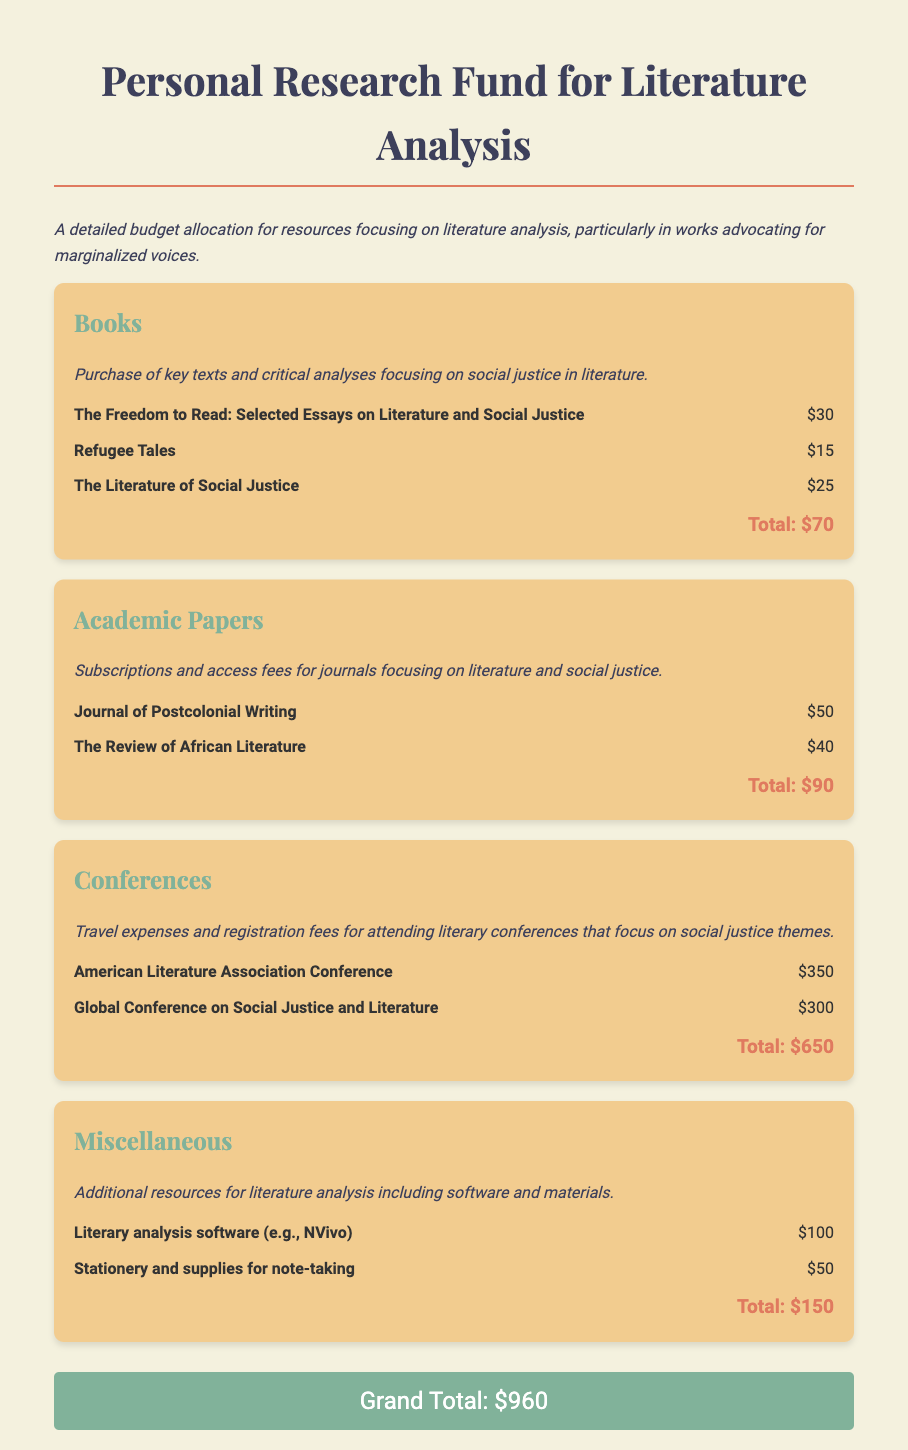What is the title of the budget document? The title of the budget document is stated clearly at the top of the rendered document.
Answer: Personal Research Fund for Literature Analysis What is the total amount allocated for books? This total is calculated from the individual costs of the books provided in the document.
Answer: $70 How much is budgeted for academic papers? The total allocated for academic papers can be found in the respective section of the document.
Answer: $90 What is the registration fee for the American Literature Association Conference? This fee is specified in the conference section of the document.
Answer: $350 What is the total amount allocated for conferences? This sum includes the costs of all listed conferences and is presented as a total in that section.
Answer: $650 What are the expenses listed under miscellaneous? This section includes costs for additional resources necessary for literature analysis.
Answer: $150 What is the grand total for the entire budget? The grand total is given at the end of the document after summing all sections.
Answer: $960 How many books are listed in the budget? The number of books can be counted from the items listed in the books section.
Answer: 3 What is the purpose of the described research fund? The purpose is outlined at the beginning of the document.
Answer: Literature analysis focusing on marginalized voices 